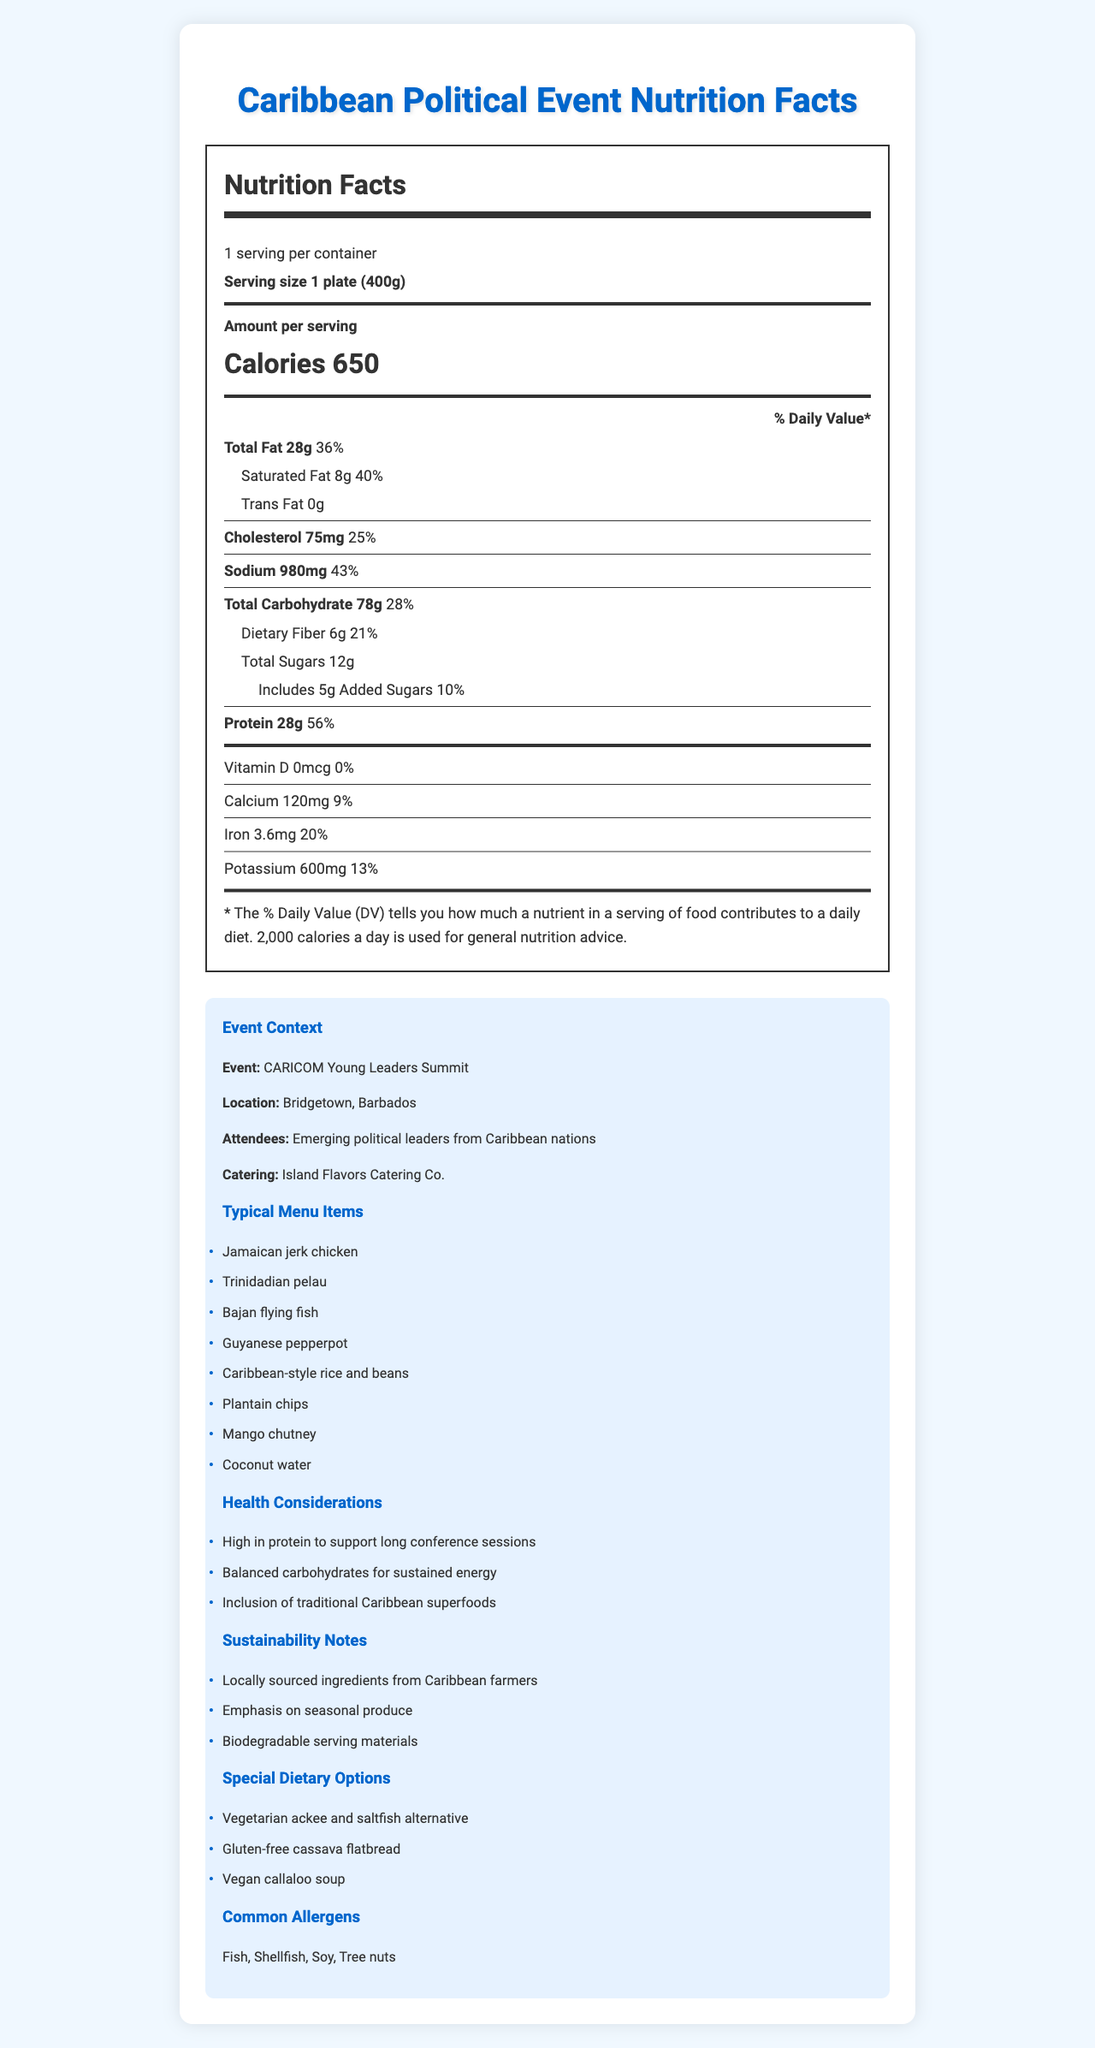what is the serving size for the food provided at the event? The serving size is clearly stated in the nutrition label as "1 plate (400g)."
Answer: 1 plate (400g) how many calories are in one serving? The nutrition label indicates that there are 650 calories per serving.
Answer: 650 what is the total fat content in one serving, and what percent of the daily value does it represent? The nutrition label shows that one serving contains 28 grams of total fat, which represents 36% of the daily value.
Answer: 28g, 36% what are the typical menu items provided by Island Flavors Catering Co. at the CARICOM Young Leaders Summit? Under the "Typical Menu Items" section, all these items are listed.
Answer: Jamaican jerk chicken, Trinidadian pelau, Bajan flying fish, Guyanese pepperpot, Caribbean-style rice and beans, Plantain chips, Mango chutney, Coconut water what are some of the dietary options provided for special diets? These options are mentioned under the "Special Dietary Options" section.
Answer: Vegetarian ackee and saltfish alternative, Gluten-free cassava flatbread, Vegan callaloo soup how much protein does one serving contain, and how does it contribute to the daily value percentage? The nutrition label states that one serving has 28 grams of protein, which accounts for 56% of the daily value.
Answer: 28g, 56% In which city is the CARICOM Young Leaders Summit being held? The location is specified in the political context as "Bridgetown, Barbados."
Answer: Bridgetown, Barbados how much dietary fiber is in each serving and what percentage of the daily value does this represent? The nutrition label provides that each serving contains 6 grams of dietary fiber, which represents 21% of the daily value.
Answer: 6g, 21% what factors relate to the sustainability of the event's catering? These are listed under "Sustainability Notes."
Answer: Locally sourced ingredients from Caribbean farmers, Emphasis on seasonal produce, Biodegradable serving materials what are the common allergens present in the menu? The common allergens are stated in the "Common Allergens" section.
Answer: Fish, Shellfish, Soy, Tree nuts what is the amount of sodium in each serving? A. 500mg B. 980mg C. 1200mg D. 600mg The nutrition label specifies that each serving contains 980mg of sodium.
Answer: B. 980mg how much iron is in one serving? A. 1.2mg B. 2.4mg C. 3.6mg D. 4.8mg The nutrition label indicates there are 3.6mg of iron in one serving.
Answer: C. 3.6mg are there any added sugars in the meal provided? The nutrition label shows that there are 5 grams of added sugars, which represent 10% of the daily value.
Answer: Yes is this meal high in protein? The label shows that one serving contains 28 grams of protein, accounting for 56% of the daily value, which is relatively high.
Answer: Yes summarize the nutritional content and context of the event's catering. The explanation covers both the nutritional content provided in the label and the context of the event's catering, including health and sustainability notes.
Answer: The catering for the CARICOM Young Leaders Summit in Bridgetown, Barbados, offers nutritionally dense food, with a serving size of 1 plate (400g) containing 650 calories. Each serving has 28g of total fat (36% DV), 75mg cholesterol (25% DV), 980mg sodium (43% DV), 78g total carbohydrates (28% DV), 6g dietary fiber (21% DV), 12g total sugars, 5g added sugars (10% DV), and 28g protein (56% DV). The catering emphasizes sustainability and offers special dietary options. what is the catering company's name for the event? The political context section mentions that the catering company is Island Flavors Catering Co.
Answer: Island Flavors Catering Co. what are the vitamin D and calcium content in each serving? The nutrition label shows that each serving contains 0mcg of Vitamin D and 120mg of calcium.
Answer: Vitamin D: 0mcg, Calcium: 120mg what specific Caribbean superfoods are included in the menu? The document states the inclusion of traditional Caribbean superfoods but does not specify which ones are included.
Answer: Not enough information 